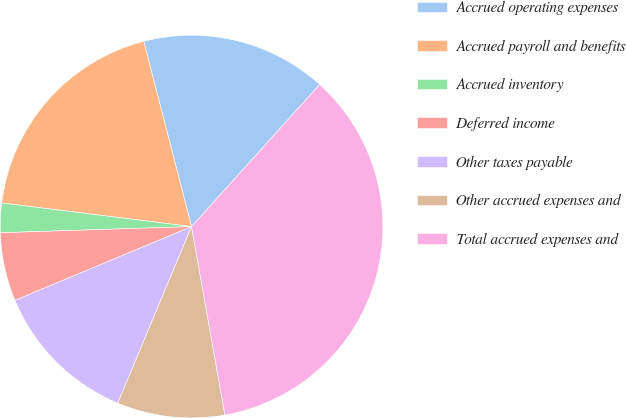Convert chart to OTSL. <chart><loc_0><loc_0><loc_500><loc_500><pie_chart><fcel>Accrued operating expenses<fcel>Accrued payroll and benefits<fcel>Accrued inventory<fcel>Deferred income<fcel>Other taxes payable<fcel>Other accrued expenses and<fcel>Total accrued expenses and<nl><fcel>15.7%<fcel>19.01%<fcel>2.48%<fcel>5.79%<fcel>12.4%<fcel>9.09%<fcel>35.53%<nl></chart> 